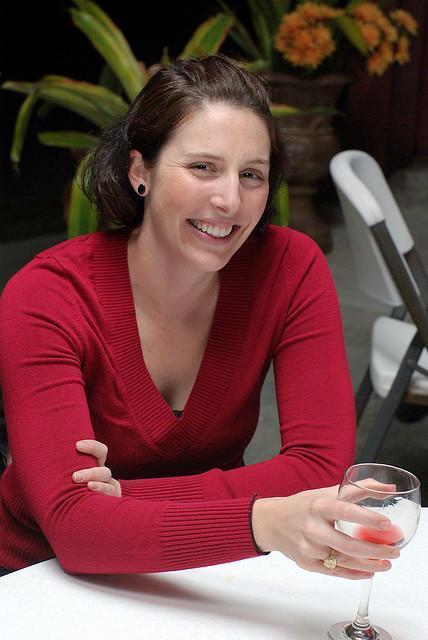What drink goes in this type of glass?
Choose the right answer from the provided options to respond to the question.
Options: Coffee, tea, beer, wine. Wine. 